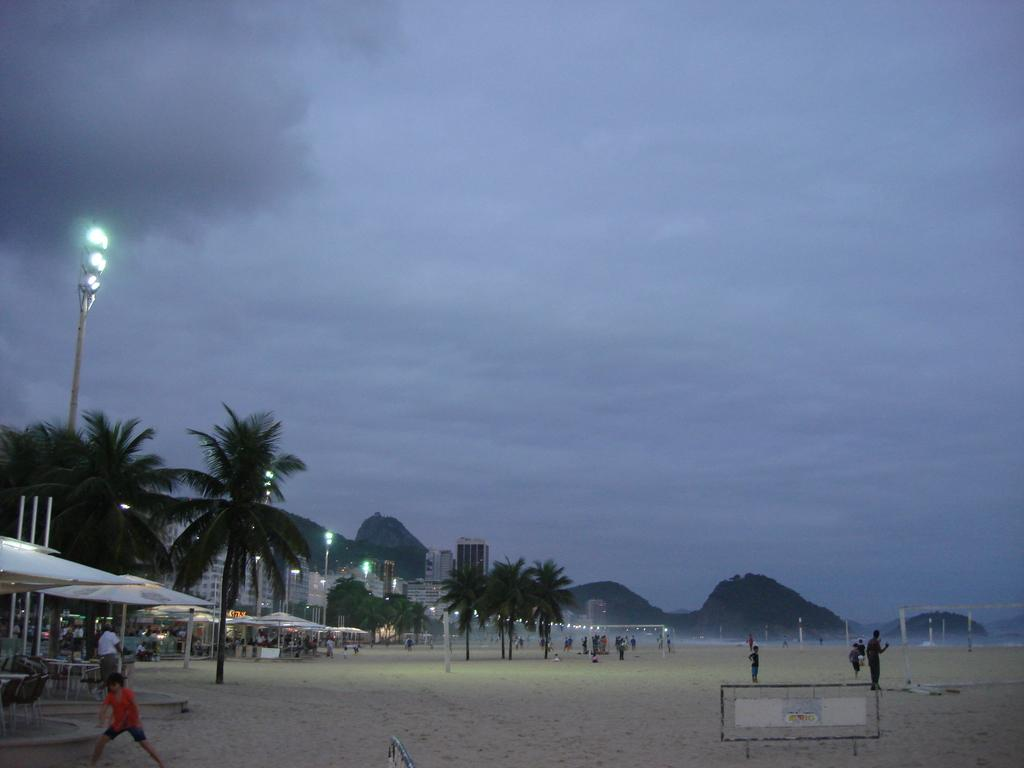What is the main setting of the image? The main setting of the image is the sand, where many people are present. What can be seen to the left of the image? There are tents, trees, light poles, and buildings to the left of the image. What is visible in the background of the image? Mountains and the sky are visible in the background of the image. How many fingers can be seen on the toes of the people in the image? There are no fingers or toes visible on the people in the image, as they are standing on the sand. What type of grass is growing on the mountains in the background? There is no grass visible on the mountains in the background; only the mountains themselves can be seen. 